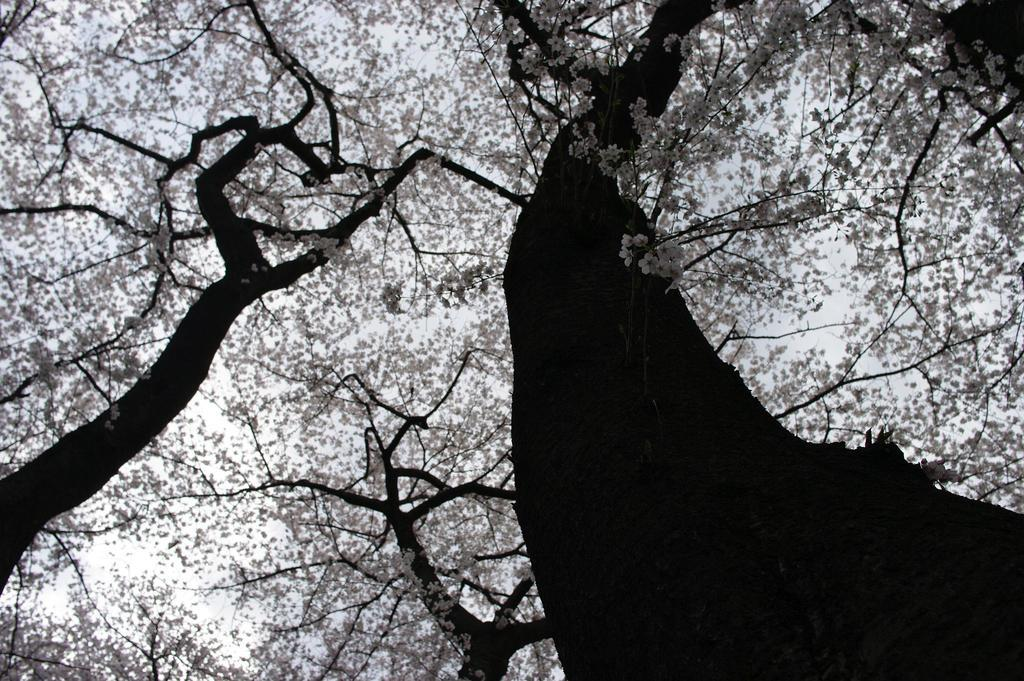What is the color scheme of the image? The image is black and white. What type of vegetation can be seen in the image? There are trees with flowers in the image. What can be seen in the background of the image? There is sky visible in the background of the image. How many dogs are visible in the image? There are no dogs present in the image; it features trees with flowers and a black and white color scheme. What type of verse can be read from the image? There is no verse present in the image; it is a black and white photograph of trees with flowers. 